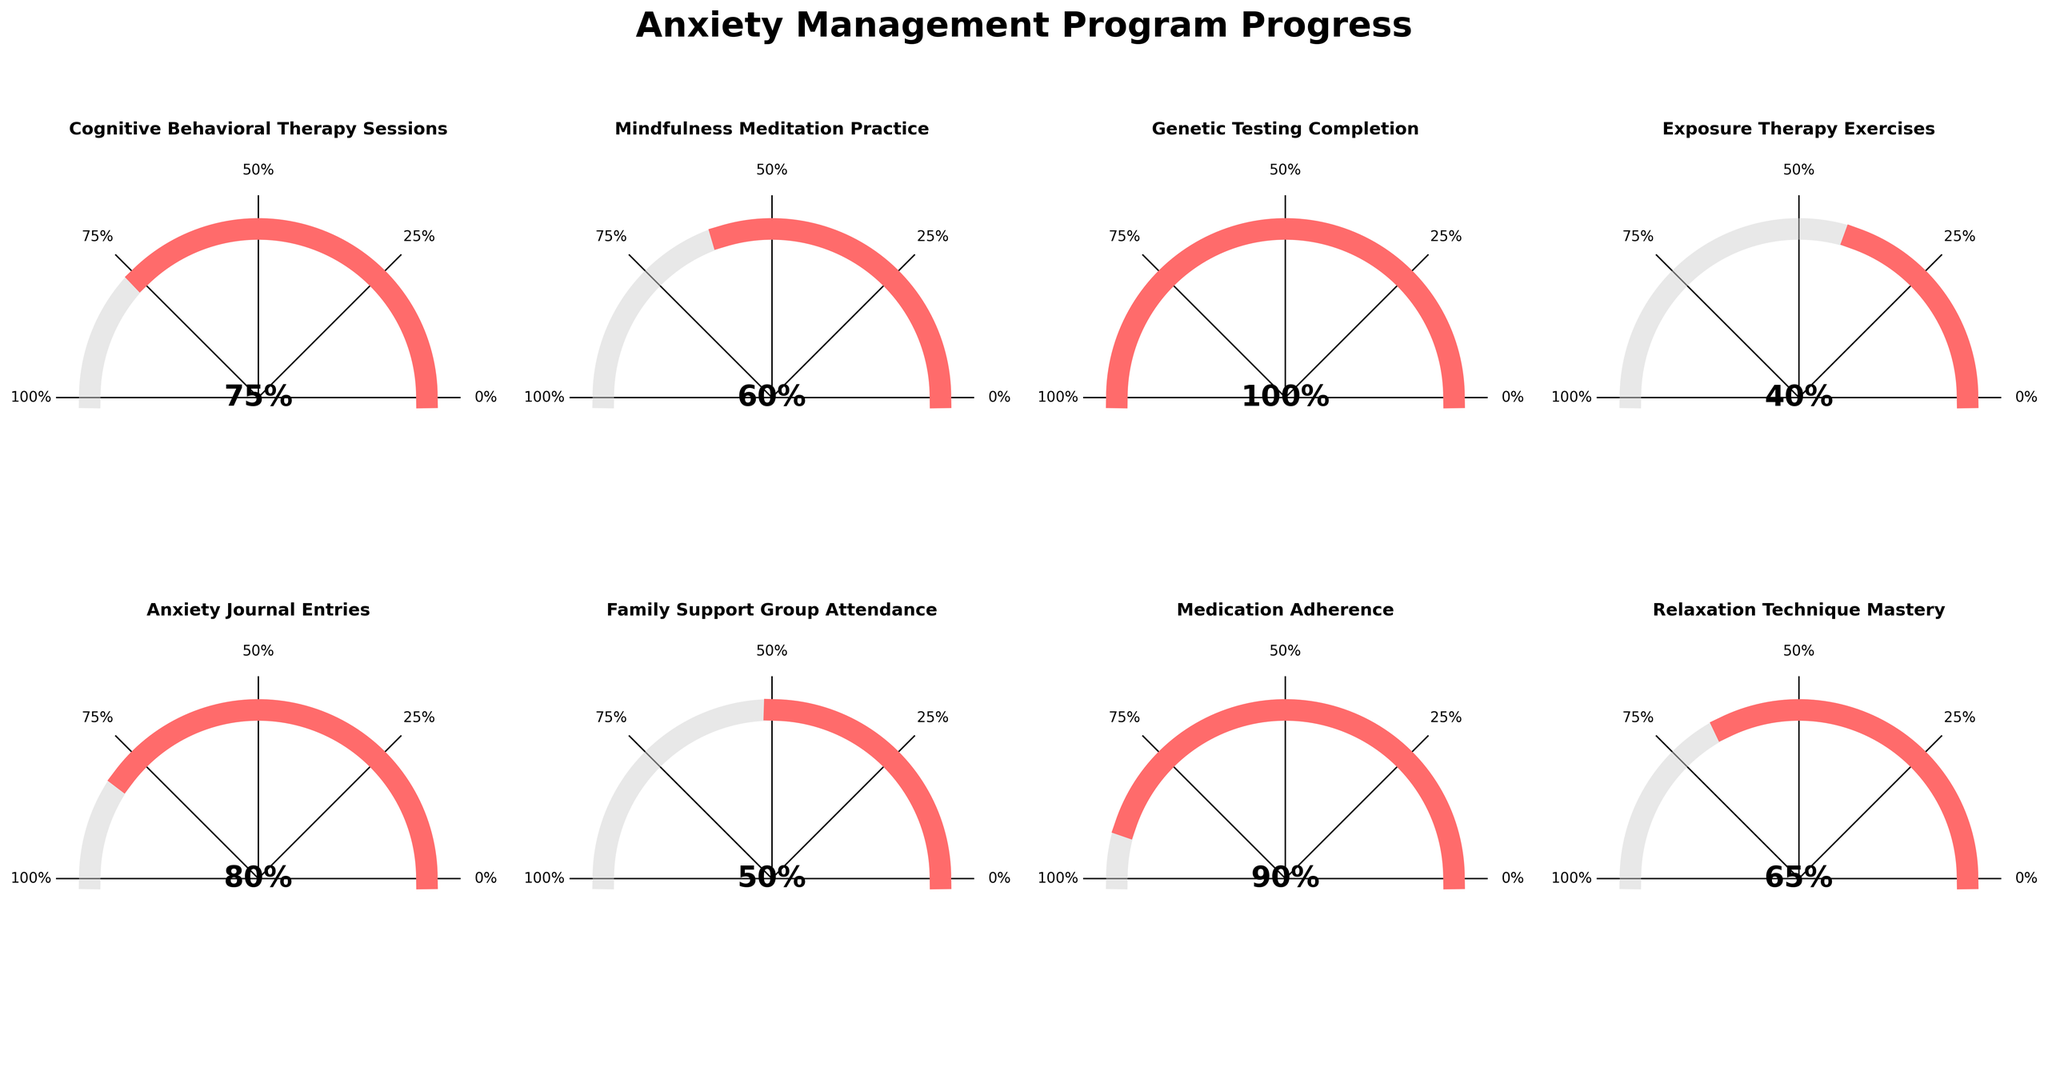What's the highest milestone progress? The milestone with the highest progress is identified by looking at the percent completion indicators in each gauge chart. The "Genetic Testing Completion" shows 100%, which is the highest.
Answer: Genetic Testing Completion Which milestone has the lowest progress? To find the milestone with the lowest progress, check each gauge chart and identify the one with the smallest percent completion. "Exposure Therapy Exercises" shows 40%, which is the lowest.
Answer: Exposure Therapy Exercises What's the progress percentage for Mindfulness Meditation Practice? Look at the gauge chart labeled "Mindfulness Meditation Practice" and read the progress value displayed in the center. It shows 60%.
Answer: 60% How many milestones have a progress of 75% or more? Count the number of gauge charts that show a progress indicator of greater than or equal to 75%. These are "Cognitive Behavioral Therapy Sessions" (75%), "Genetic Testing Completion" (100%), "Anxiety Journal Entries" (80%), and "Medication Adherence" (90%). There are 4 of them.
Answer: 4 What's the average progress percentage across all milestones? Sum the progress percentages of all milestones and then divide by the number of milestones. The values are: 75, 60, 100, 40, 80, 50, 90, and 65. The average is (75 + 60 + 100 + 40 + 80 + 50 + 90 + 65) / 8 = 70%.
Answer: 70% Which has a higher progress, Family Support Group Attendance or Relaxation Technique Mastery? Compare the progress of "Family Support Group Attendance" (50%) and "Relaxation Technique Mastery" (65%). "Relaxation Technique Mastery" has a higher progress.
Answer: Relaxation Technique Mastery What is the combined progress percentage for "Cognitive Behavioral Therapy Sessions" and "Exposure Therapy Exercises"? Add the progress percentages of "Cognitive Behavioral Therapy Sessions" (75%) and "Exposure Therapy Exercises" (40%). The combined progress is 75 + 40 = 115%.
Answer: 115% How does the progress for Medication Adherence compare to Exposure Therapy Exercises? Compare the progress percentages of "Medication Adherence" (90%) and "Exposure Therapy Exercises" (40%). "Medication Adherence" has a higher progress.
Answer: Medication Adherence is higher What is the median progress percentage of all milestones? Arrange the progress values in ascending order: 40, 50, 60, 65, 75, 80, 90, 100. The median value is the middle one in the sorted list. For 8 values, the median is the average of the 4th and 5th values: (65 + 75) / 2 = 70%.
Answer: 70% Which milestones have progress exactly at 60%? Look for gauge charts that display a progress value of exactly 60%. "Mindfulness Meditation Practice" shows 60%.
Answer: Mindfulness Meditation Practice 